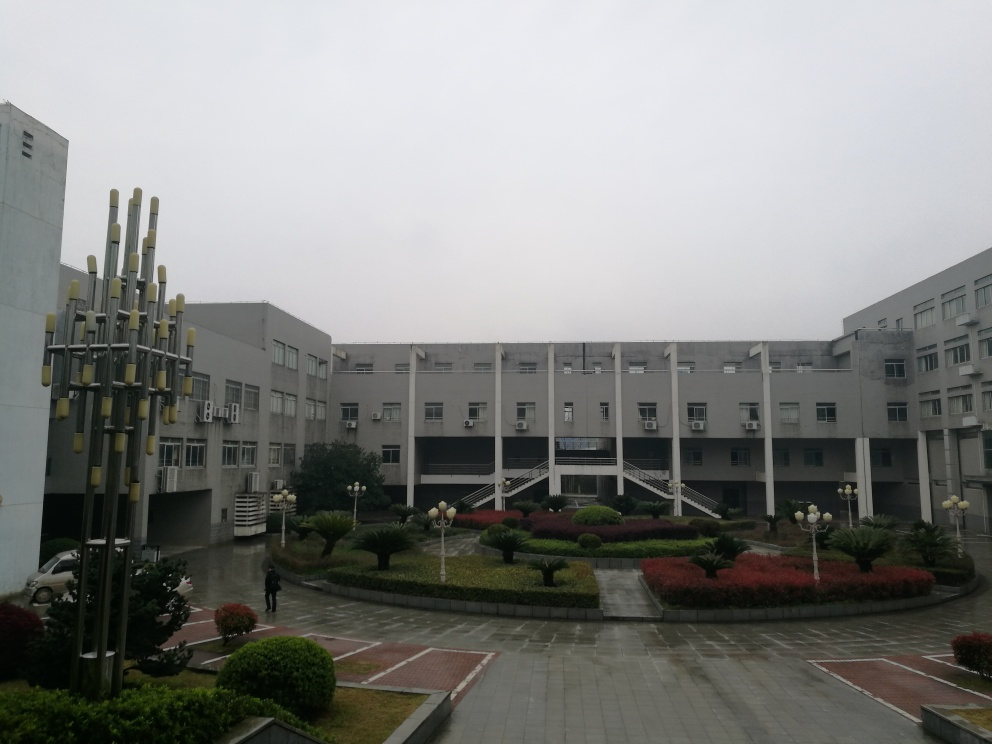Can you tell me what the weather is like in this image? The sky is overcast, implying it's a cloudy day. The light is diffuse, without strong shadows, typical of an overcast or foggy day. There is no visible precipitation, but the atmosphere suggests it might be cool and possibly damp. 